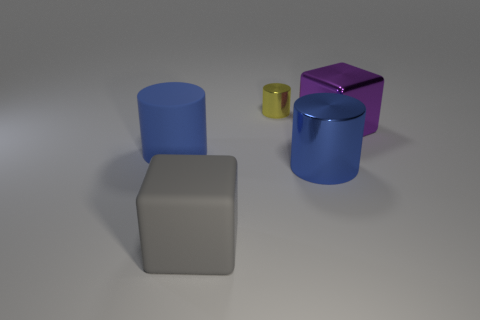Is there another large purple object made of the same material as the big purple object?
Your response must be concise. No. Is the material of the big purple object the same as the gray cube?
Provide a short and direct response. No. What number of cylinders are blue shiny things or large purple shiny objects?
Your response must be concise. 1. What is the color of the block that is made of the same material as the yellow thing?
Make the answer very short. Purple. Is the number of large metal blocks less than the number of large cubes?
Offer a very short reply. Yes. There is a blue thing that is left of the big blue shiny cylinder; is it the same shape as the big gray matte object that is left of the big purple thing?
Offer a very short reply. No. How many objects are either spheres or tiny yellow metallic objects?
Your answer should be very brief. 1. What color is the matte block that is the same size as the purple object?
Provide a succinct answer. Gray. There is a big block on the left side of the large purple thing; what number of large blue cylinders are right of it?
Your answer should be compact. 1. What number of things are both behind the large blue metal thing and on the right side of the yellow shiny cylinder?
Your response must be concise. 1. 